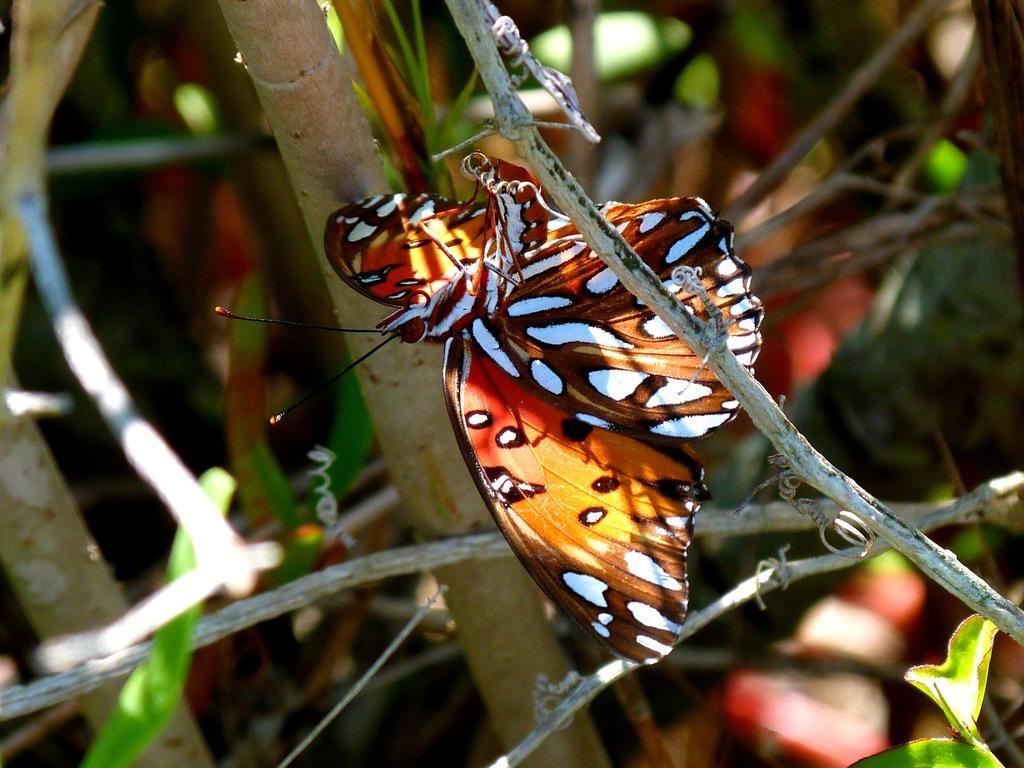How would you summarize this image in a sentence or two? This picture is clicked outside. In the center there is an orange colored moth sitting on the branch of a tree. In the background we can see the stems and some other objects. 